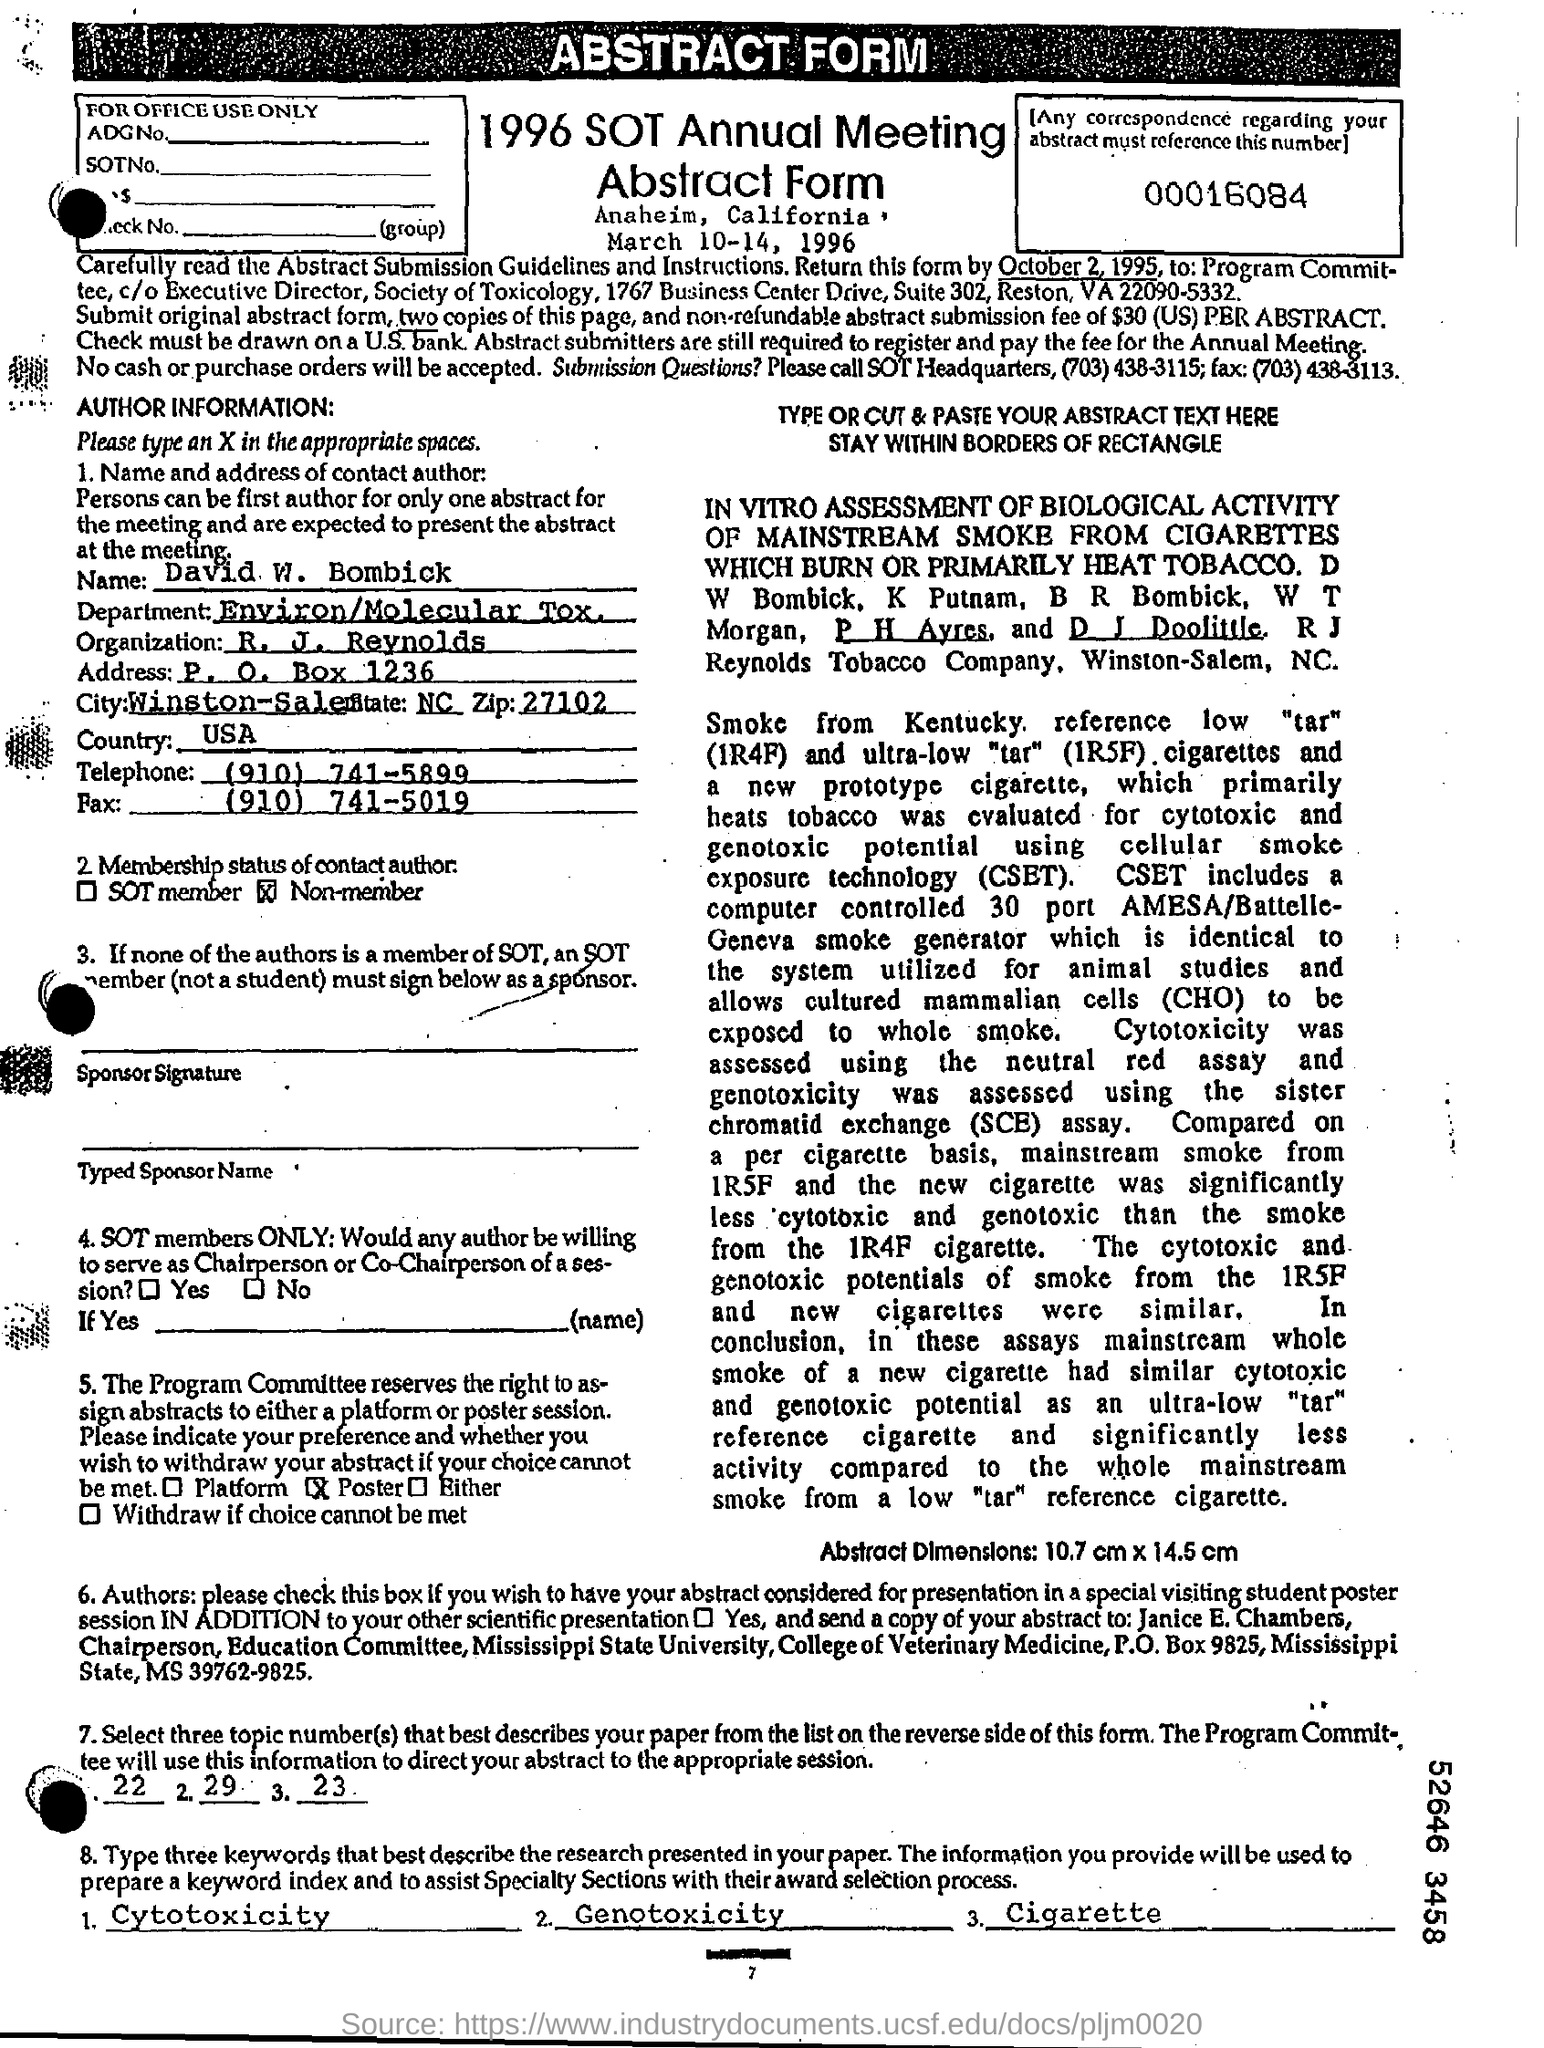Identify some key points in this picture. The fax number is (910) 741-5019. The author's name is David W. Bombick. The telephone number is (910) 741-5899. The top of the document contains an abstract form. The mention in the Department Field is "Environment/Molecular Toxicology. 